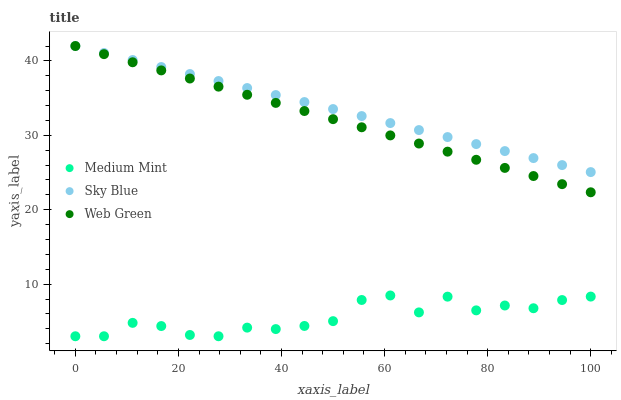Does Medium Mint have the minimum area under the curve?
Answer yes or no. Yes. Does Sky Blue have the maximum area under the curve?
Answer yes or no. Yes. Does Web Green have the minimum area under the curve?
Answer yes or no. No. Does Web Green have the maximum area under the curve?
Answer yes or no. No. Is Web Green the smoothest?
Answer yes or no. Yes. Is Medium Mint the roughest?
Answer yes or no. Yes. Is Sky Blue the smoothest?
Answer yes or no. No. Is Sky Blue the roughest?
Answer yes or no. No. Does Medium Mint have the lowest value?
Answer yes or no. Yes. Does Web Green have the lowest value?
Answer yes or no. No. Does Web Green have the highest value?
Answer yes or no. Yes. Is Medium Mint less than Web Green?
Answer yes or no. Yes. Is Web Green greater than Medium Mint?
Answer yes or no. Yes. Does Web Green intersect Sky Blue?
Answer yes or no. Yes. Is Web Green less than Sky Blue?
Answer yes or no. No. Is Web Green greater than Sky Blue?
Answer yes or no. No. Does Medium Mint intersect Web Green?
Answer yes or no. No. 